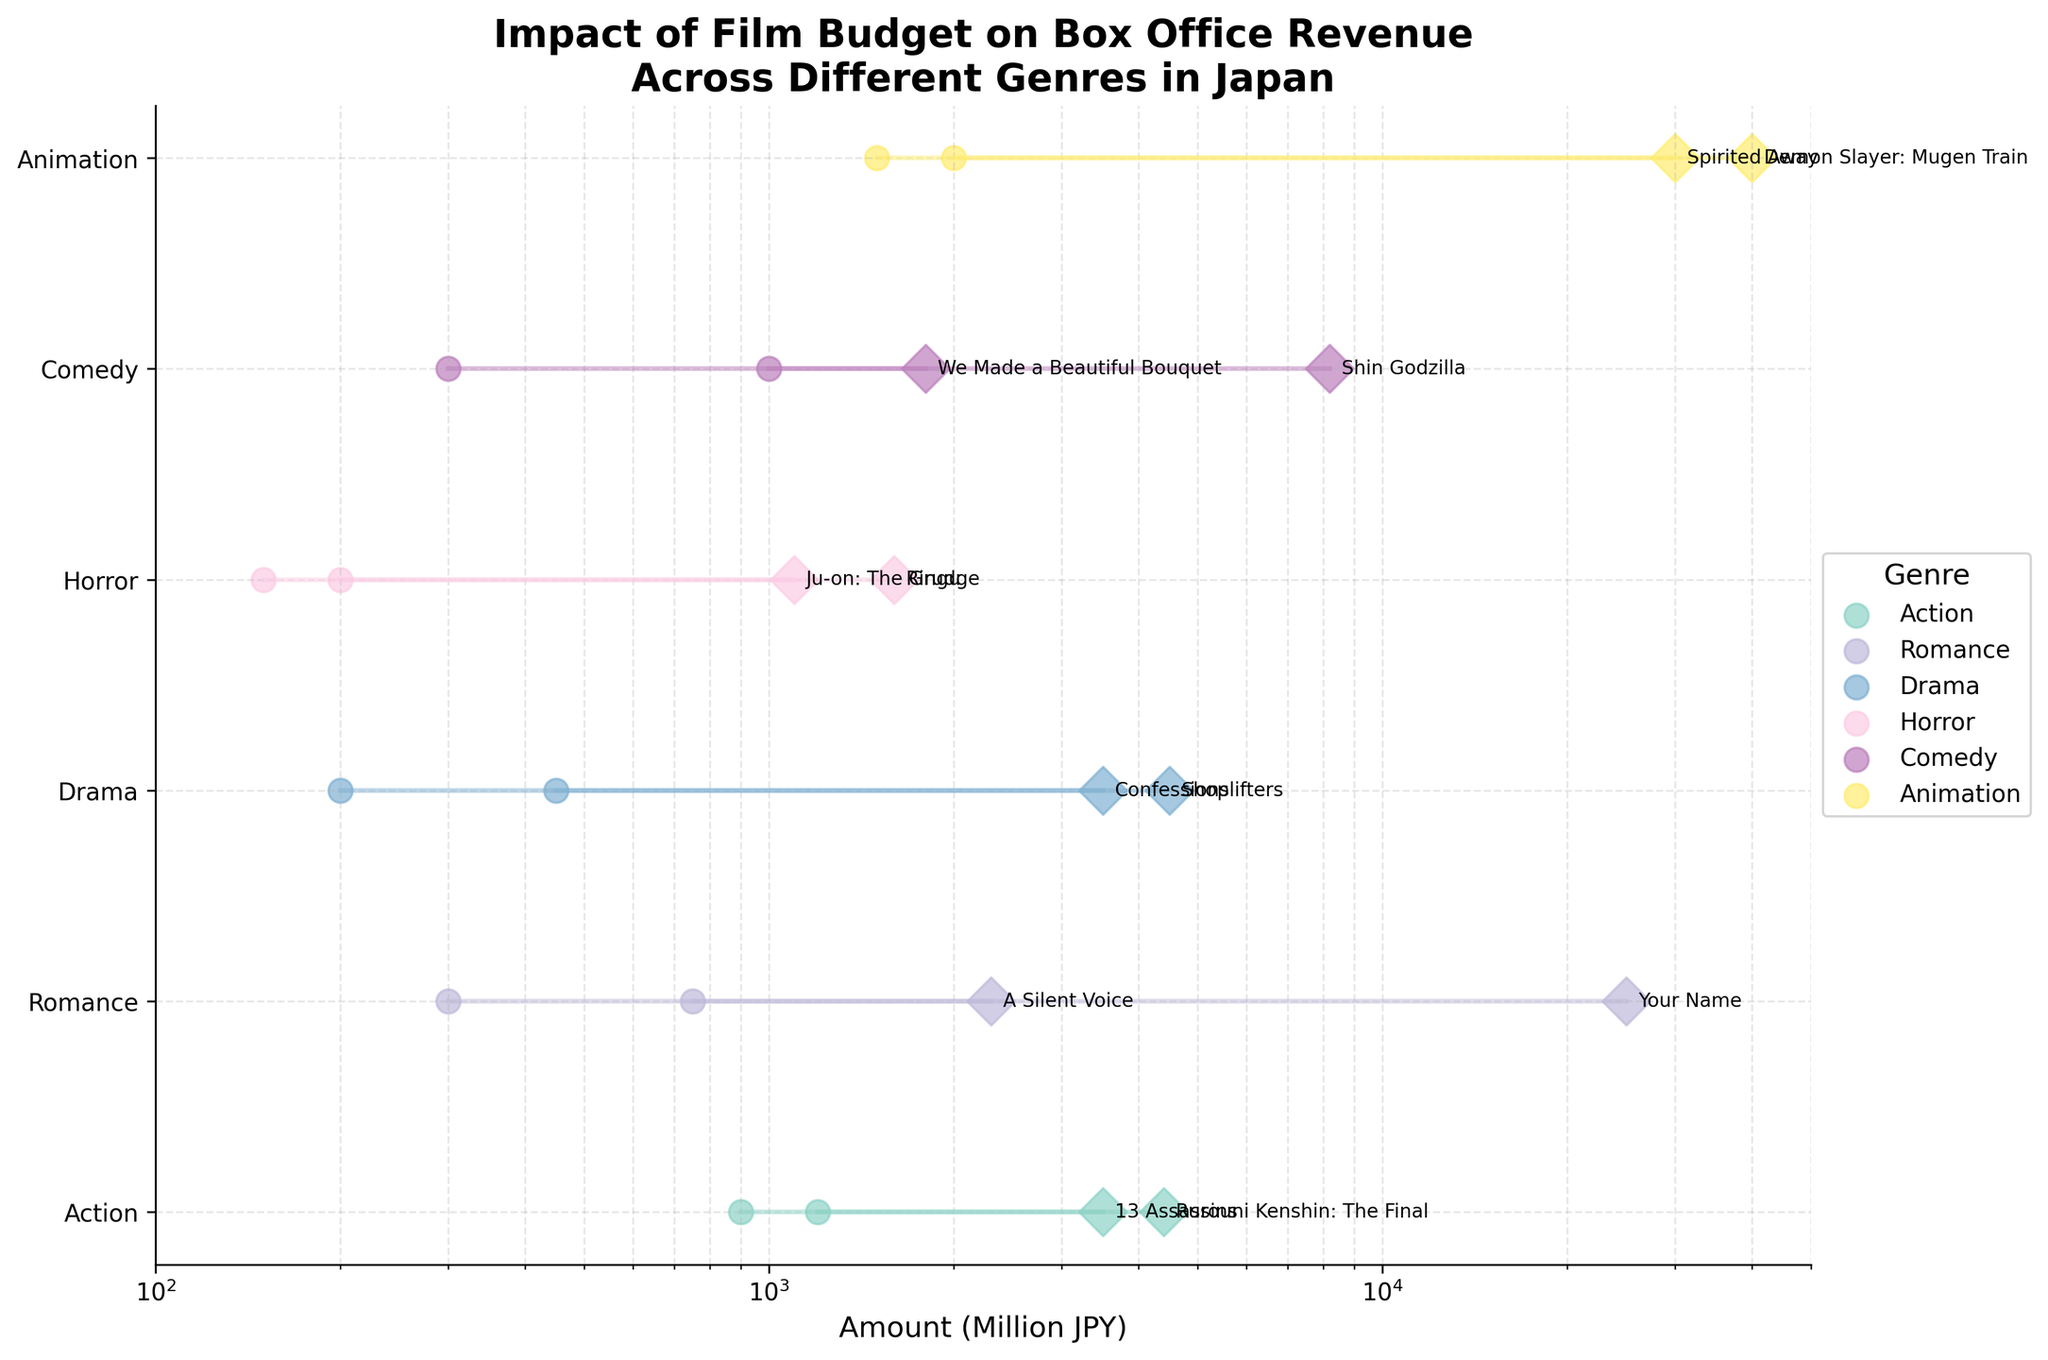What's the title of the plot? The title of the plot is displayed at the top of the figure. It reads "Impact of Film Budget on Box Office Revenue Across Different Genres in Japan".
Answer: "Impact of Film Budget on Box Office Revenue Across Different Genres in Japan" How are the y-axis values labeled? The y-axis values are labeled with the different genres of films. Each genre is represented by a different tick mark along the y-axis.
Answer: Different film genres Which genre has the highest box office revenue for a single movie, and what is that revenue? According to the plot, Animation has the highest box office revenue for a single movie. By looking at the data points on the right side of the Animation row, the highest box office revenue is for "Demon Slayer: Mugen Train", which is ¥40,000 million.
Answer: Animation, ¥40,000 million How many genres are represented in the plot? By counting the unique ticks along the y-axis, we can see that there are 6 different genres represented in the plot: Action, Romance, Drama, Horror, Comedy, and Animation.
Answer: 6 genres In which genre is the largest difference between film budget and box office revenue observed? The largest difference can be identified by comparing the length of the line segments connecting the budget and revenue for each genre. The longest line is observed in the Animation genre between "Demon Slayer: Mugen Train" with a budget of ¥1500 million and a revenue of ¥40,000 million.
Answer: Animation Which genre has the lowest average film budget? To find the average film budget for each genre, sum the budgets of each film within a genre and divide by the number of films in that genre. Calculation: 
Action: (900 + 1200) / 2 = 1050
Romance: (750 + 300) / 2 = 525
Drama: (450 + 200) / 2 = 325
Horror: (200 + 150) / 2 = 175
Comedy: (1000 + 300) / 2 = 650
Animation: (2000 + 1500) / 2 = 1750
The lowest average film budget is found in the Horror genre.
Answer: Horror Compare the box office revenues of the highest and lowest performing movies in the Drama genre. The highest box office revenue in the Drama genre is for "Shoplifters" at ¥4,500 million, and the lowest is for "Confessions" at ¥3,500 million. The difference between them can be calculated directly: 4,500 - 3,500 = 1,000 million JPY.
Answer: ¥1,000 million Which film had the highest box office revenue in the Romance genre, and how much was it? In the Romance genre, the film "Your Name" had the highest box office revenue. By checking the data point, it shows a revenue of ¥25,000 million.
Answer: "Your Name", ¥25,000 million What is the median box office revenue for all the films shown in the plot? To find the median, list all box office revenues in ascending order and find the middle value. If the number of data points is even, take the average of the two middle values:
1,100; 1,600; 1,800; 2,300; 3,500; 3,500; 4,400; 4,500; 8,200; 25,000; 30,000; 40,000 The median is the average of the 6th and 7th values (3,500 + 4,400) / 2 = 3,950 million JPY.
Answer: ¥3,950 million How much more revenue did "Shin Godzilla" generate compared to its budget? By referring to the Comedy genre, "Shin Godzilla" has a box office revenue of ¥8,200 million and a budget of ¥1,000 million. The difference is 8,200 - 1,000 = 7,200 million JPY.
Answer: ¥7,200 million 